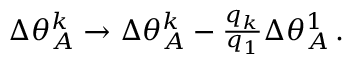Convert formula to latex. <formula><loc_0><loc_0><loc_500><loc_500>\begin{array} { r } { \Delta \theta _ { A } ^ { k } \rightarrow \Delta \theta _ { A } ^ { k } - \frac { q _ { k } } { q _ { 1 } } \Delta \theta _ { A } ^ { 1 } \, . } \end{array}</formula> 